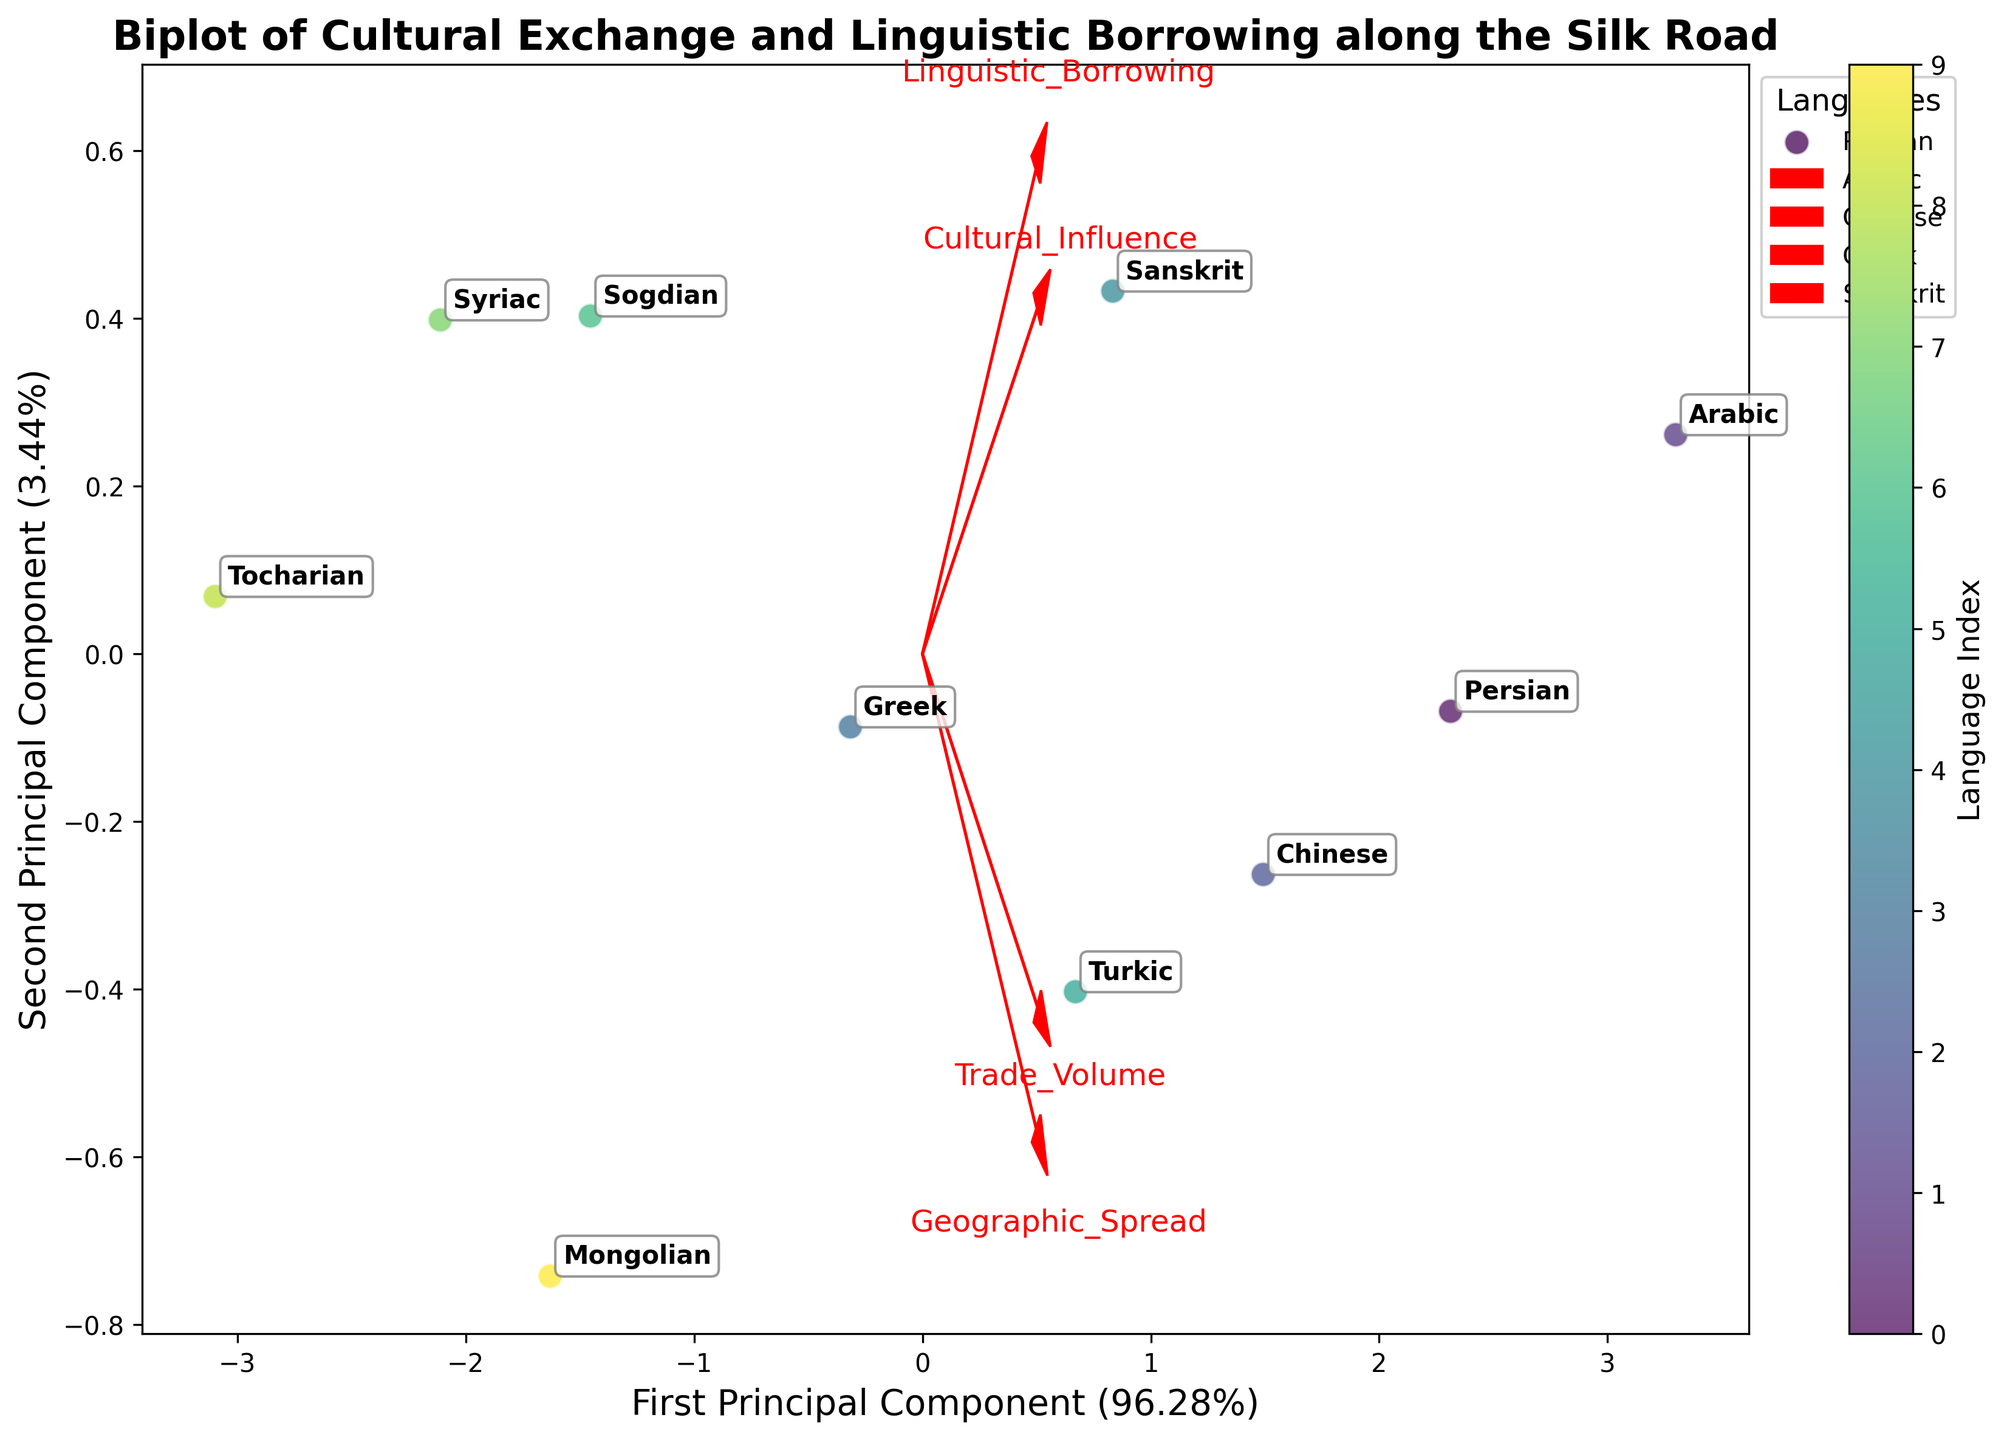What's the title of the plot? The title is displayed at the top of the plot.
Answer: Biplot of Cultural Exchange and Linguistic Borrowing along the Silk Road How many different languages are represented in the plot? Each data point in the scatter plot represents a different language. Count the number of unique points.
Answer: 10 Which language has the highest values for both Cultural Influence and Linguistic Borrowing? Locate the points relating to Cultural Influence and Linguistic Borrowing in the feature vectors and identify the language positioned farthest in the positive direction of both vectors.
Answer: Arabic Which feature vector extends the farthest to the right along the First Principal Component? Look at the arrows representing the feature vectors and see which one extends the most to the right.
Answer: Trade Volume What percentage of the total variance is explained by the First Principal Component? Locate the label on the x-axis, which mentions the percentage variance explained by the First Principal Component.
Answer: 48% Which language is most similar to Persian in terms of its position in the PCA space? Look at the positions of the languages in the PCA scatter plot and find the one closest to Persian.
Answer: Arabic Which two features seem to have the greatest impact on the languages' positions in the PCA space? Analyze the length and direction of all the feature vectors. The longest and most aligned with the distribution of languages impact the most.
Answer: Trade Volume and Cultural Influence Is Cultural Influence more aligned with the First or the Second Principal Component? Observe the direction of the 'Cultural Influence' arrow and which principal component axis it aligns more closely with.
Answer: First Principal Component Arrange the languages in descending order according to their Trade Volume. Compare the positions of the languages concerning the Trade Volume vector. Identify their relative magnitudes.
Answer: Arabic, Persian, Chinese, Mongolian, Turkic, Sanskrit, Greek, Sogdian, Syriac, Tocharian Which language shows the least geographic spread? Identify the positions of the languages and determine which has the smallest component along the 'Geographic_Spread' vector.
Answer: Syriac 